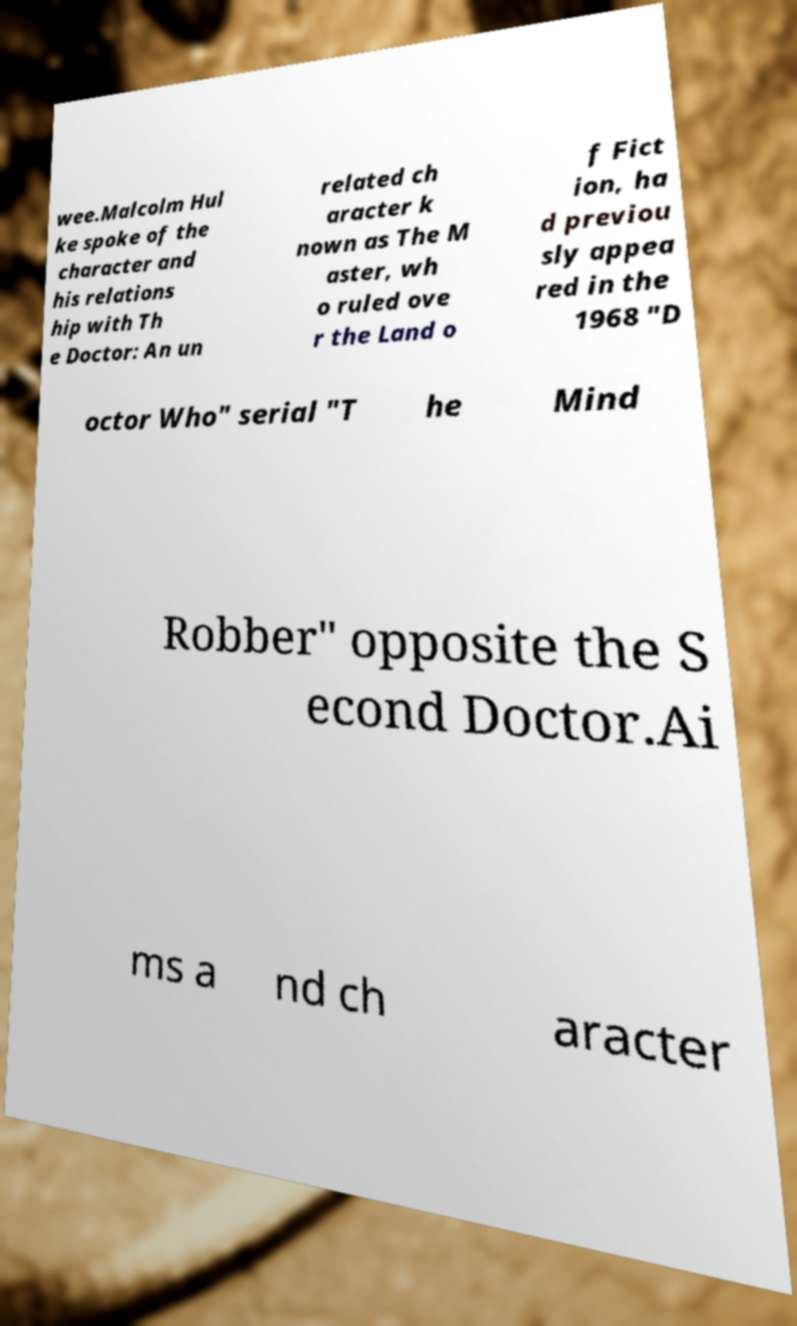Can you read and provide the text displayed in the image?This photo seems to have some interesting text. Can you extract and type it out for me? wee.Malcolm Hul ke spoke of the character and his relations hip with Th e Doctor: An un related ch aracter k nown as The M aster, wh o ruled ove r the Land o f Fict ion, ha d previou sly appea red in the 1968 "D octor Who" serial "T he Mind Robber" opposite the S econd Doctor.Ai ms a nd ch aracter 